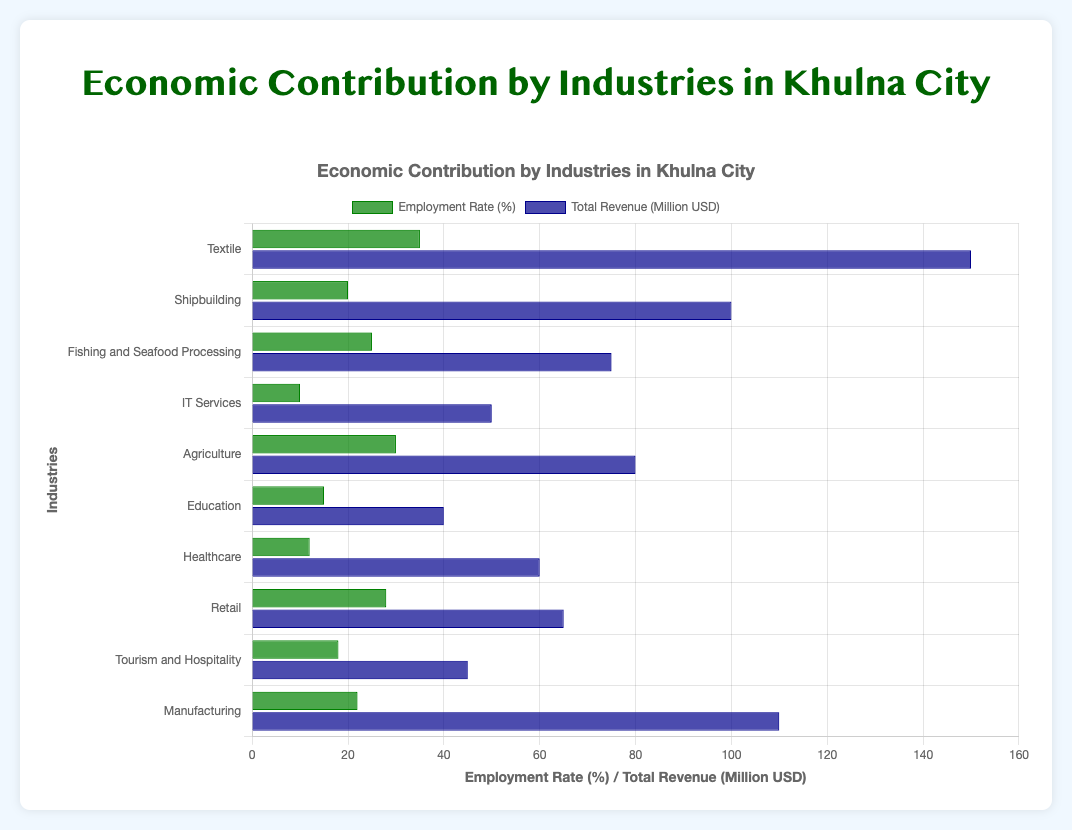Which industry has the highest employment rate? The industry with the highest employment rate can be identified by looking at the bar in the 'Employment Rate (%)' dataset that extends the farthest to the right.
Answer: Textile Which industries have an employment rate above 25%? Identify the industries where the 'Employment Rate (%)' bars extend beyond the 25% mark on the horizontal axis.
Answer: Textile, Fishing and Seafood Processing, Agriculture, Retail Which industry generates the lowest total revenue in million USD? The industry with the lowest total revenue is shown by the bar in the 'Total Revenue (Million USD)' dataset that extends the least to the right.
Answer: Education Comparing Shipbuilding and Manufacturing, which industry has a higher employment rate and which has a higher total revenue? Compare the lengths of the respective bars for Shipbuilding and Manufacturing in both datasets. Shipbuilding has a shorter employment rate bar and a shorter total revenue bar compared to Manufacturing.
Answer: Manufacturing has higher employment rate and higher total revenue What is the combined employment rate of IT Services, Education, and Healthcare? Add the employment rates of IT Services (10%), Education (15%), and Healthcare (12%). The combined rate is 10% + 15% + 12% = 37%.
Answer: 37% Which industry has a higher total revenue, Agriculture or Retail? Compare the total revenue bars of Agriculture and Retail. The industry with the longer bar has the higher total revenue.
Answer: Agriculture Is the total revenue of Shipbuilding more or less than 100 million USD? Observe the length of the total revenue bar for Shipbuilding and compare it to the 100 mark.
Answer: Exactly 100 million USD What is the total revenue difference between the top revenue-generating industry and the lowest revenue-generating industry? Find the total revenue of the highest (Textile with 150 million USD) and the lowest (Education with 40 million USD) revenue-generating industries and calculate the difference. The difference is 150 - 40 = 110 million USD.
Answer: 110 million USD Which industry has an employment rate closest to the average employment rate of all industries? First, calculate the average employment rate: (35 + 20 + 25 + 10 + 30 + 15 + 12 + 28 + 18 + 22) / 10 = 21.5%. The employment rate closest to 21.5% is 22% for Manufacturing.
Answer: Manufacturing 